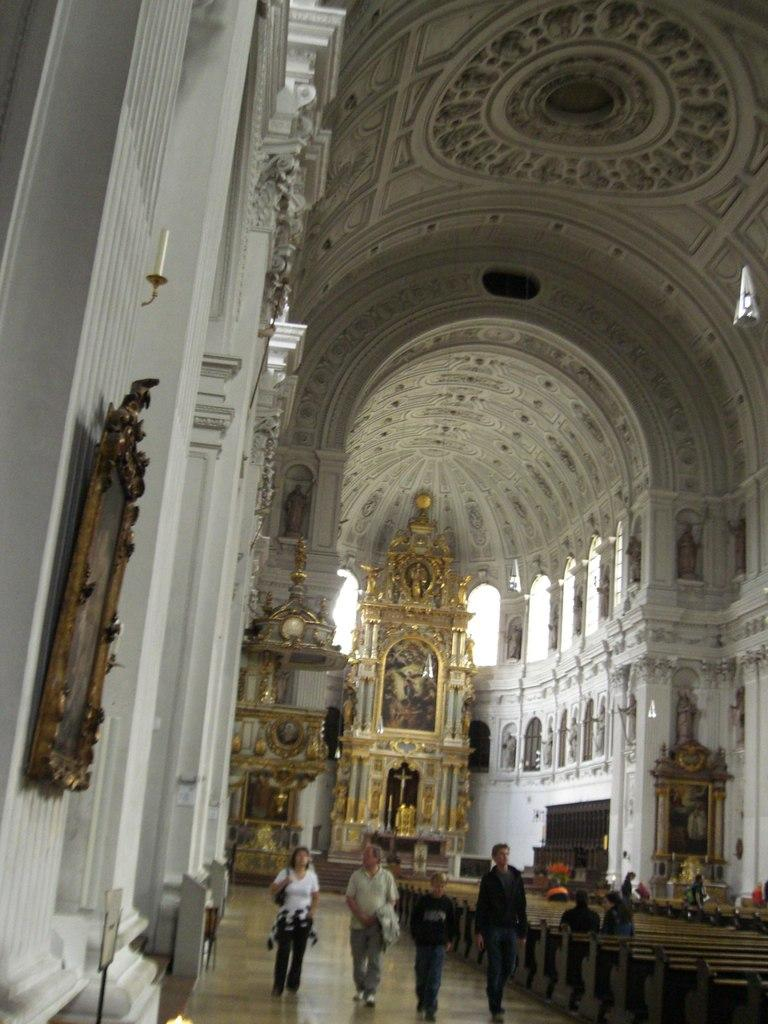What type of location is depicted in the image? The image shows an inside view of a building. Can you describe the people in the image? There is a group of people in the image. What type of furniture is present in the image? There are benches in the image. What other objects can be seen in the image? There are boards and frames attached to the walls in the image. Are there any artistic elements in the image? Yes, there are sculptures in the image. What is the route to the end of the boundary in the image? There is no route or boundary present in the image; it shows an inside view of a building with a group of people, benches, boards, frames, and sculptures. 